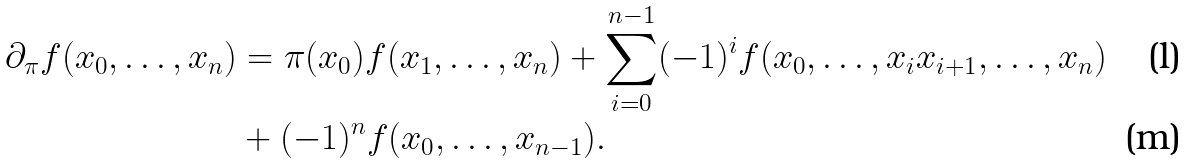<formula> <loc_0><loc_0><loc_500><loc_500>\partial _ { \pi } f ( x _ { 0 } , \dots , x _ { n } ) & = \pi ( x _ { 0 } ) f ( x _ { 1 } , \dots , x _ { n } ) + \sum _ { i = 0 } ^ { n - 1 } ( - 1 ) ^ { i } f ( x _ { 0 } , \dots , x _ { i } x _ { i + 1 } , \dots , x _ { n } ) \\ & + ( - 1 ) ^ { n } f ( x _ { 0 } , \dots , x _ { n - 1 } ) .</formula> 